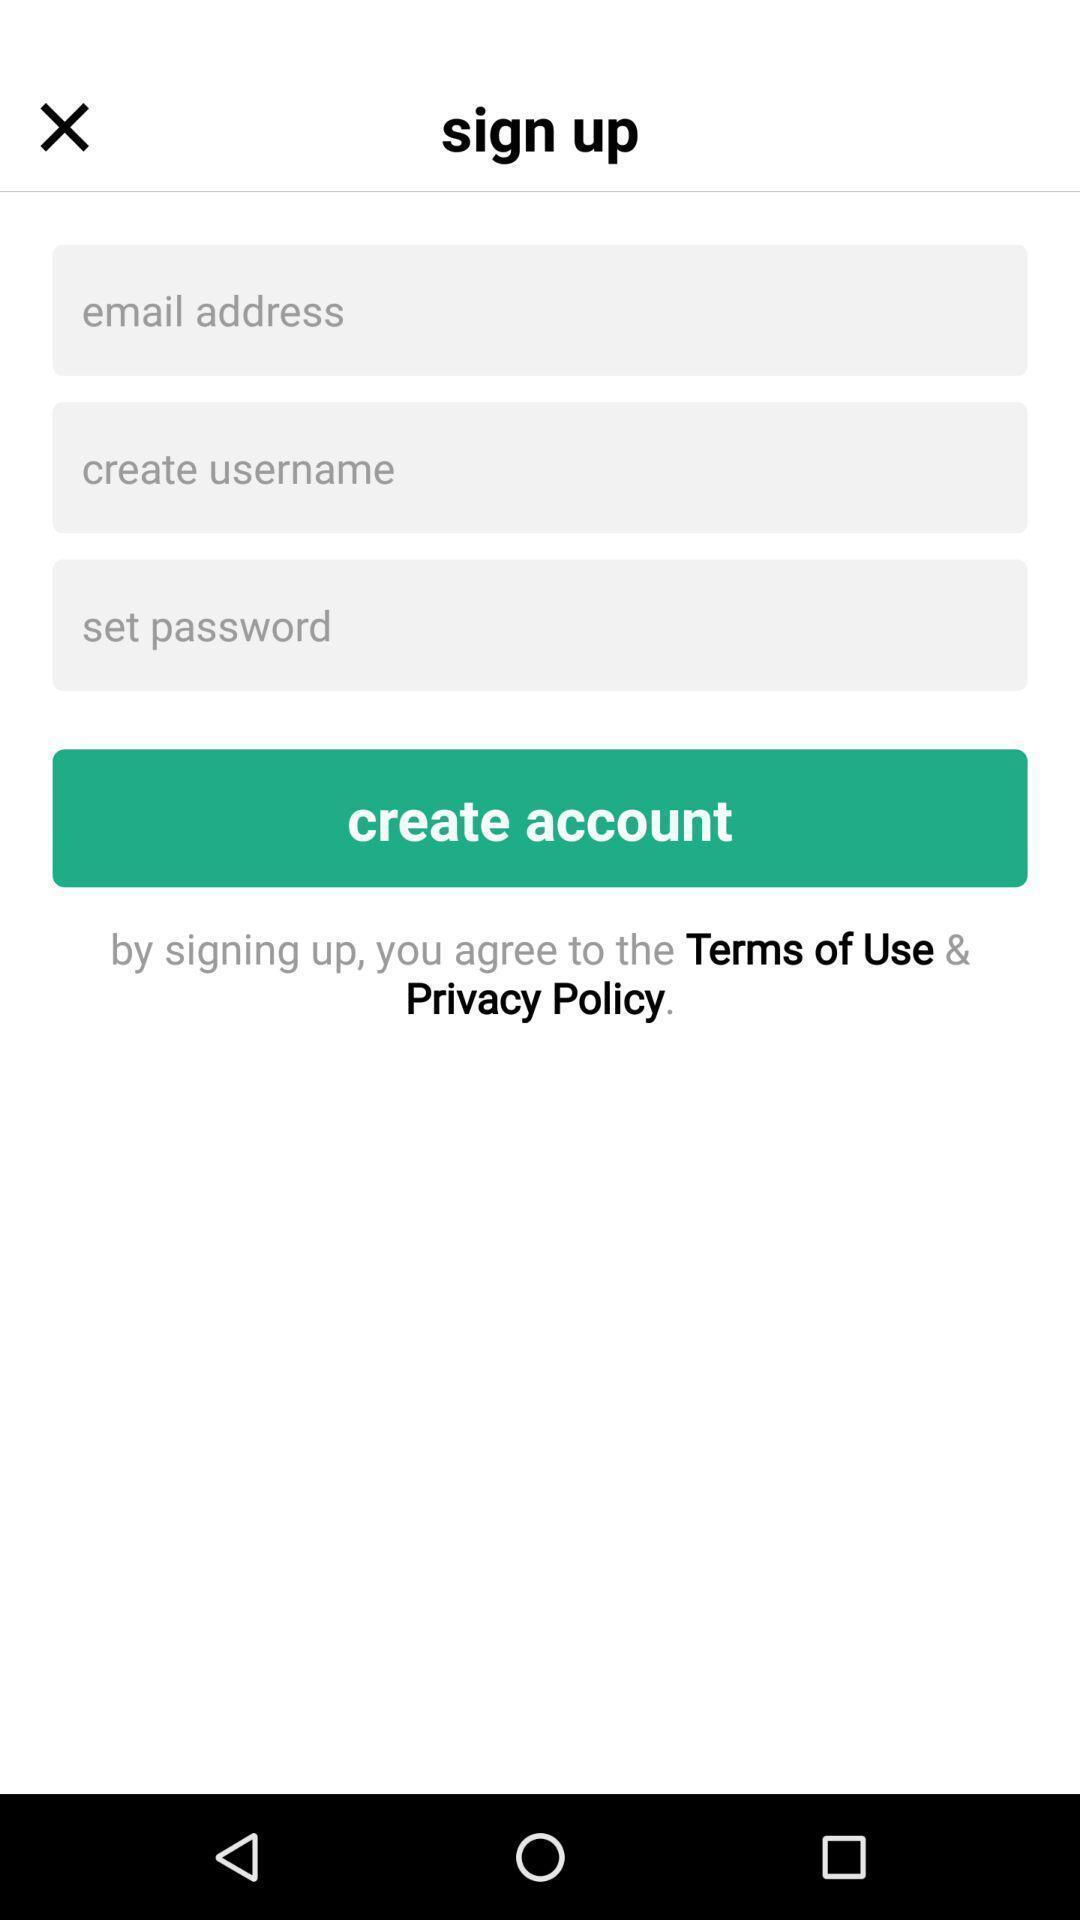Provide a textual representation of this image. Sign up page of mobile videos application. 